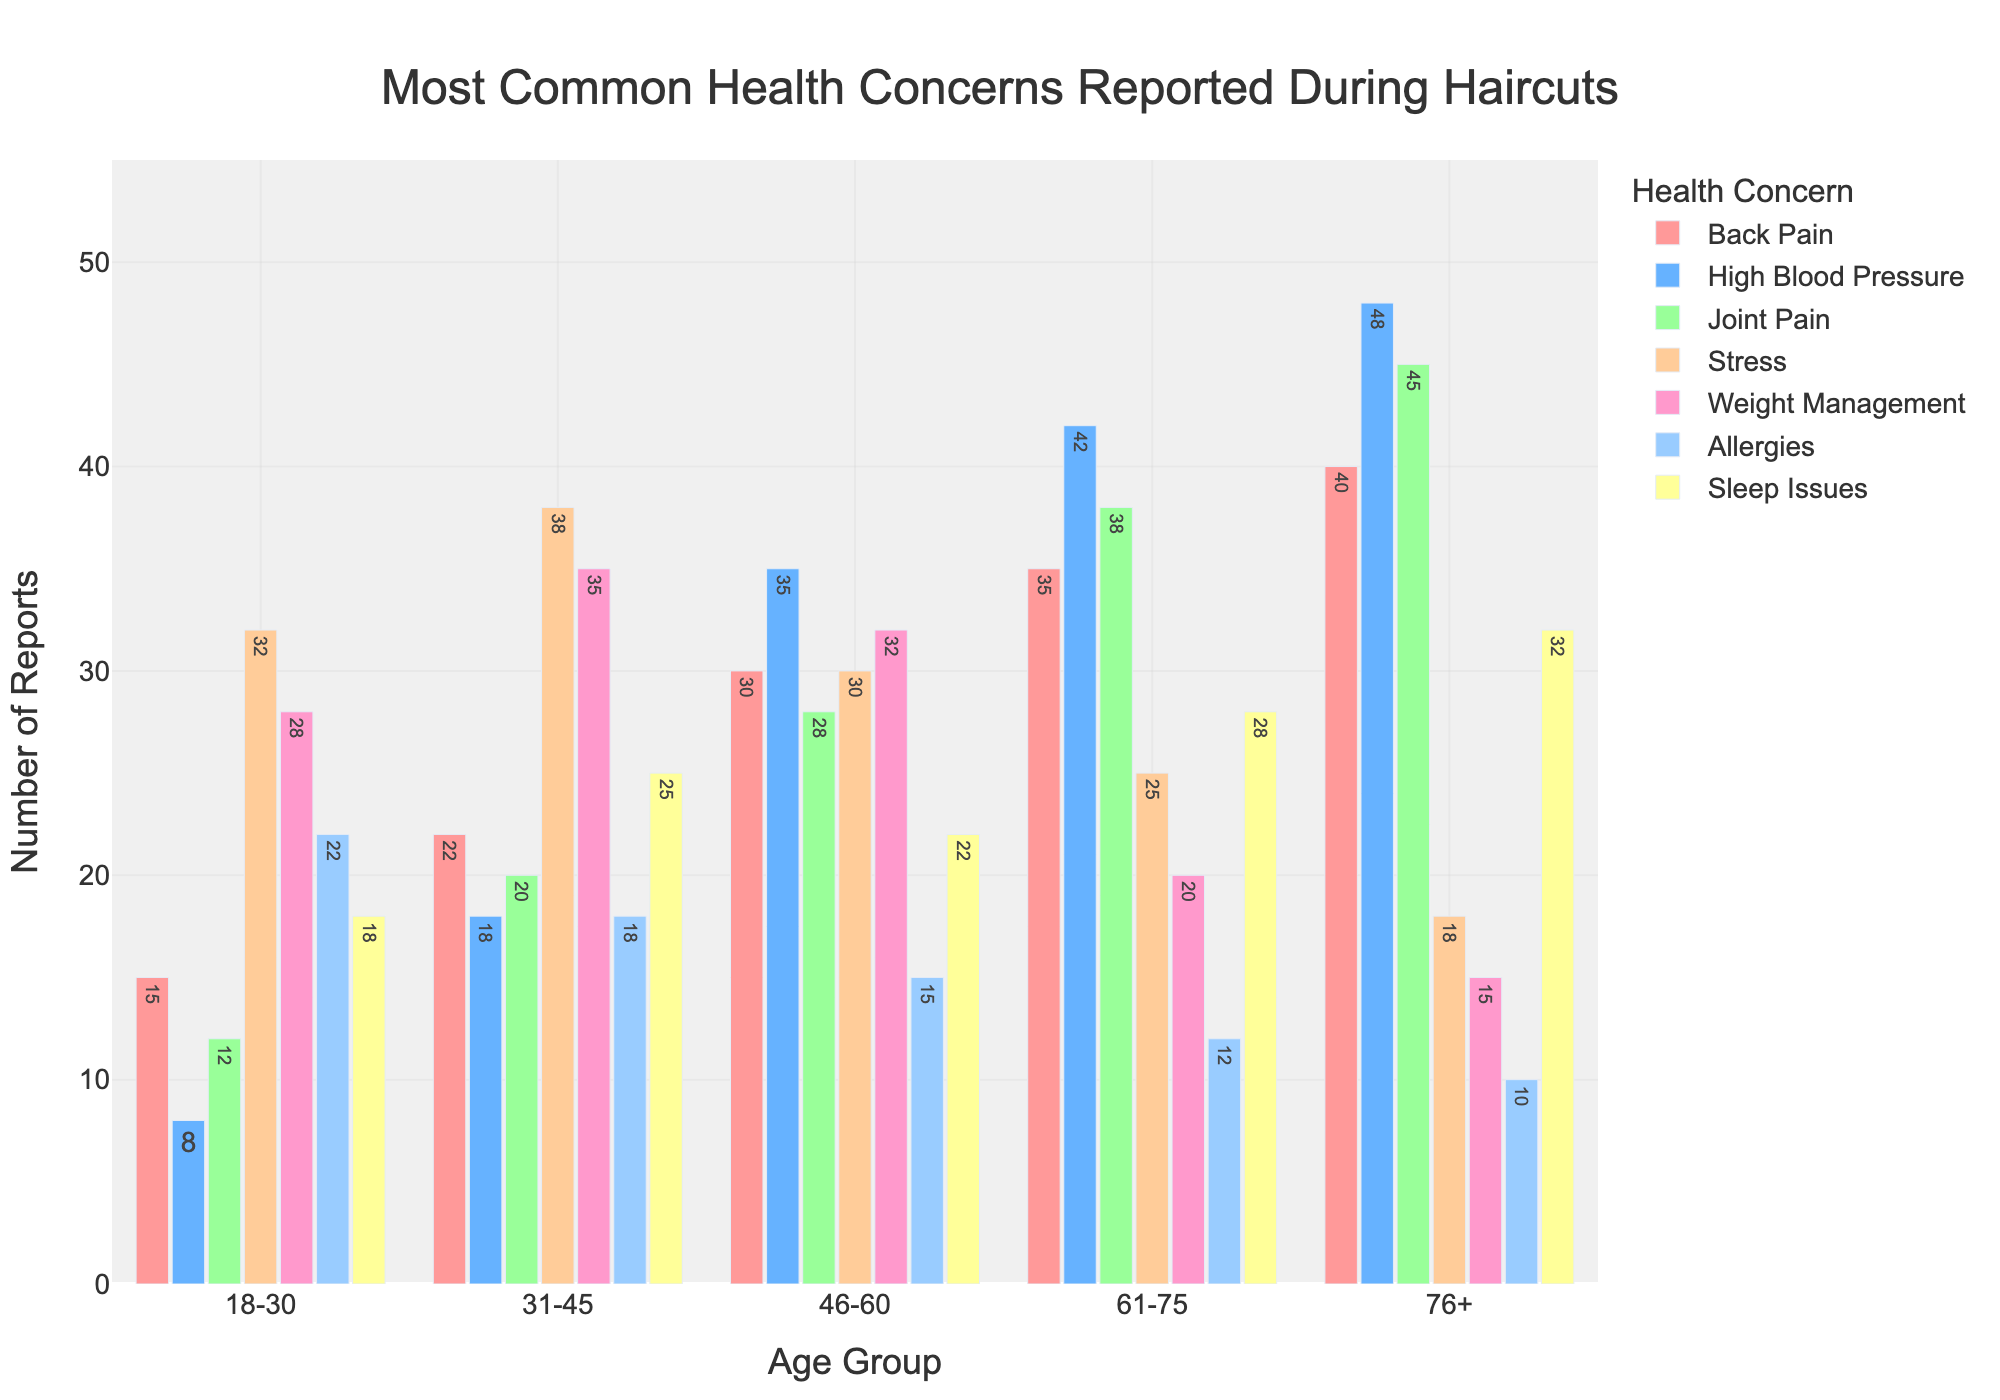Which age group reports "Back Pain" the most? Locate the bar representing "Back Pain" for each age group and identify the one with the tallest bar. The 76+ group has the tallest bar for "Back Pain" with a value of 40.
Answer: 76+ How does the number of reports for "Stress" in the 31-45 age group compare to the 18-30 age group? Find the bars representing "Stress" for the 18-30 and 31-45 age groups. The 18-30 group reports 32 instances, while the 31-45 group reports 38 instances. Compare these values.
Answer: Higher in 31-45 Which health concern has the highest number of reports in the 46-60 age group? Look at each bar within the 46-60 age group and identify the concern with the highest bar. "High Blood Pressure" has the tallest bar with a value of 35.
Answer: High Blood Pressure For the 61-75 age group, what is the combined total number of reports for "Joint Pain" and "Sleep Issues"? Find the values for "Joint Pain" (38) and "Sleep Issues" (28) in the 61-75 age group. Sum these values: 38 + 28 = 66.
Answer: 66 Which health concern shows a decreasing trend as age increases? Examine the bars for each health concern across all age groups. "Weight Management" shows a decreasing trend from 28 (18-30) to 15 (76+).
Answer: Weight Management Is the number of reports for "Allergies" in the 46-60 age group higher or lower than in the 18-30 age group? Compare the bars for "Allergies" in both age groups. The 18-30 age group has 22 reports, while the 46-60 group has 15.
Answer: Lower What is the average number of reports for "High Blood Pressure" across all age groups? Add the number of reports for "High Blood Pressure" across all age groups: 8+18+35+42+48 = 151. Then, divide by the number of age groups (5): 151/5 = 30.2
Answer: 30.2 In which age group does "Sleep Issues" have its peak and what is the report count? Locate the tallest bar for "Sleep Issues" across all age groups. The 76+ age group reports 32 instances.
Answer: 76+, 32 What is the difference in the number of reports for "Joint Pain" between the 76+ and 18-30 age groups? Find the values for "Joint Pain" in both age groups: 45 (76+) and 12 (18-30). Calculate the difference: 45 - 12 = 33.
Answer: 33 